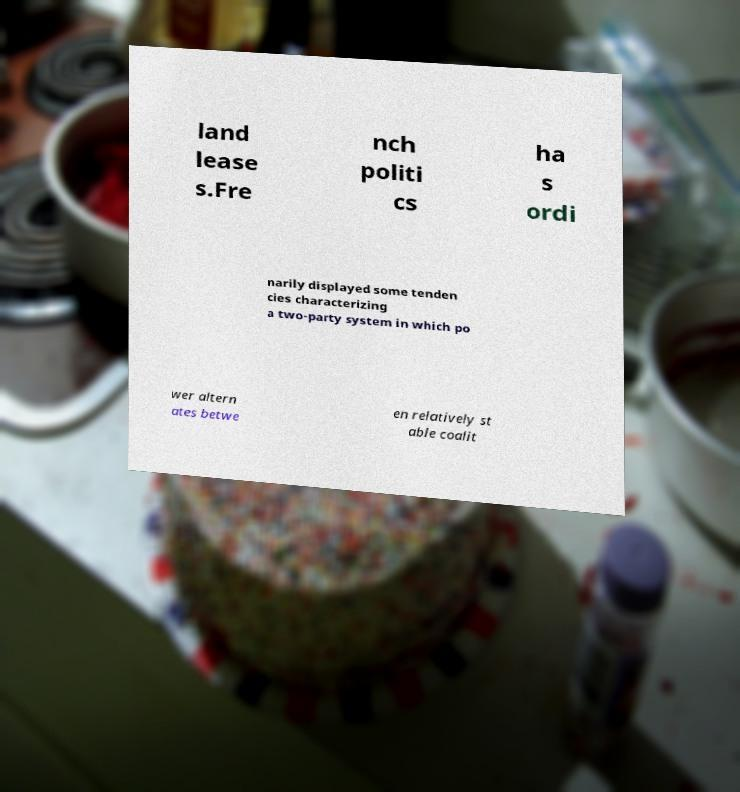Please read and relay the text visible in this image. What does it say? land lease s.Fre nch politi cs ha s ordi narily displayed some tenden cies characterizing a two-party system in which po wer altern ates betwe en relatively st able coalit 